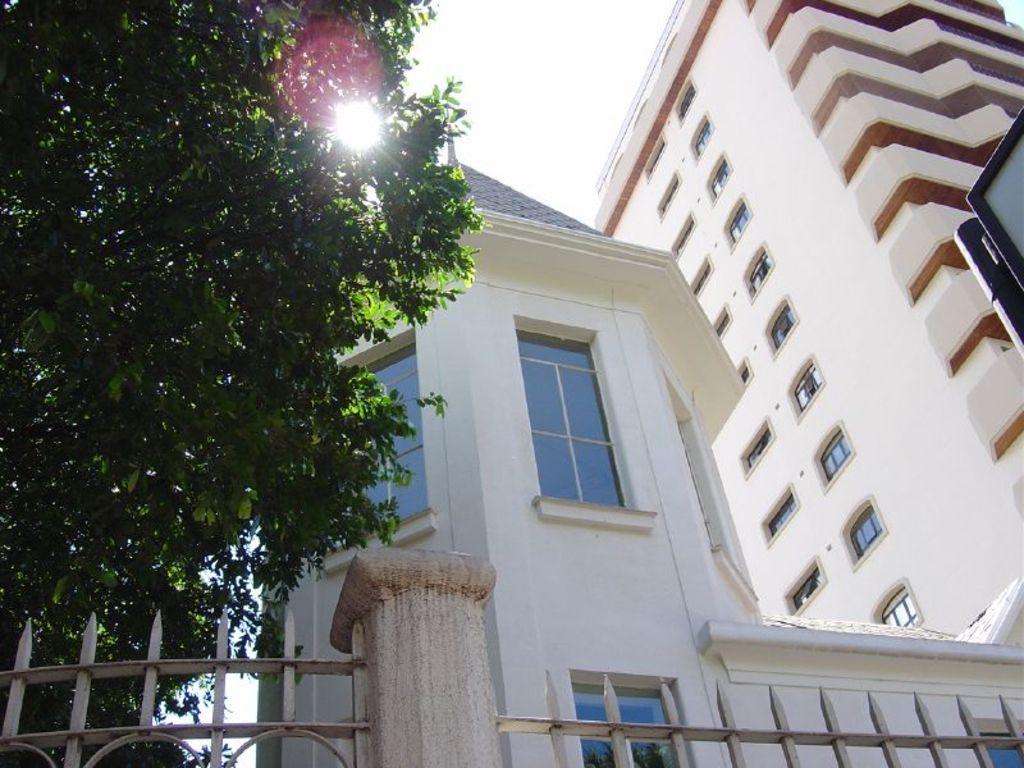Can you describe this image briefly? There is a fencing at the bottom of this image and there is a tree on the left side of this image. And there is a building on the right side of this image. There is a sky at the top of this image. 